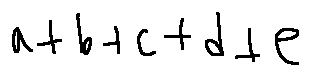<formula> <loc_0><loc_0><loc_500><loc_500>a + b + c + d + e</formula> 